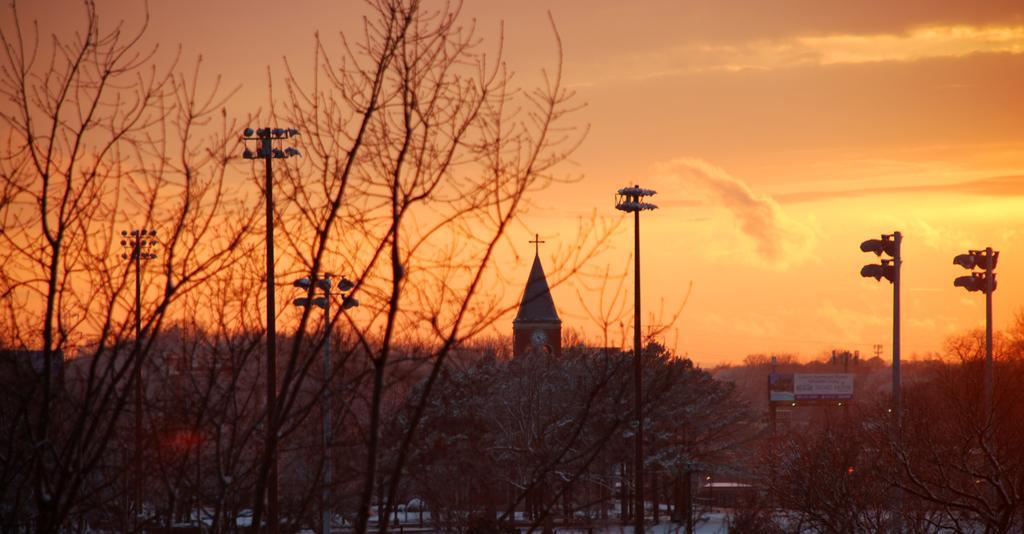How would you summarize this image in a sentence or two? In this image there are trees, polls, buildings, boards with some text and the sky. 